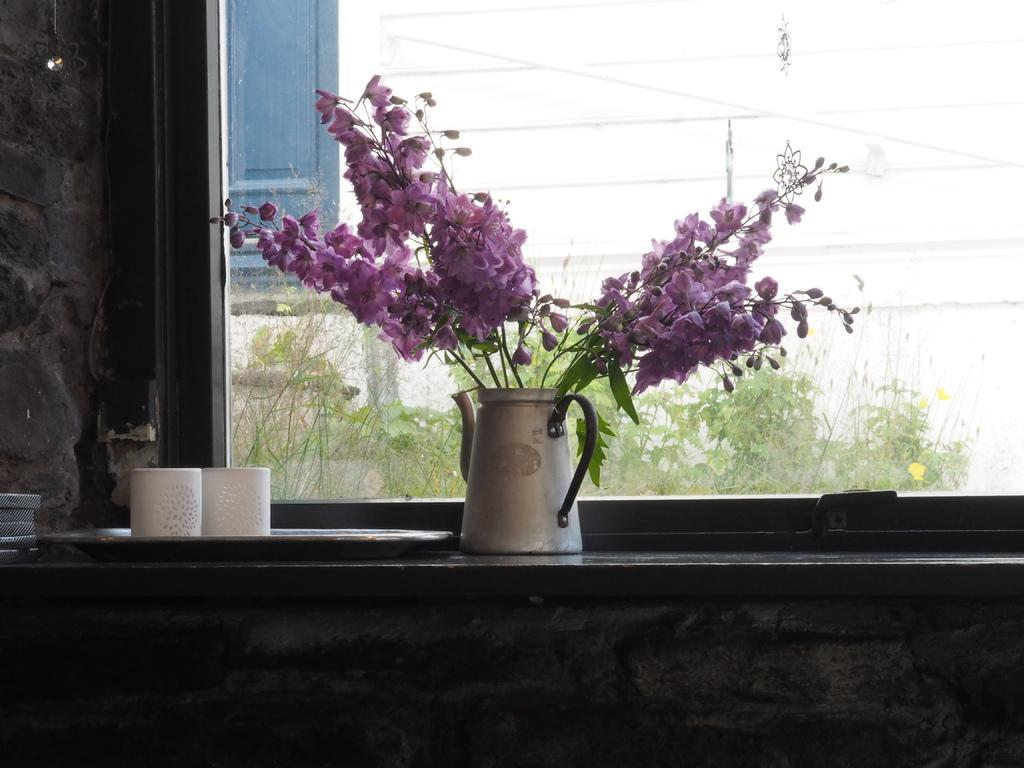What can be seen on the surface in the image? There are objects on the surface in the image. What type of natural elements are present in the image? There are trees in the image. What type of structure is visible in the image? There is a wall in the image. What allows light to enter the structure in the image? There are windows in the image. Can you see the flesh of the trees in the image? There is no mention of the trees' flesh in the image, and it is not visible in the provided facts. Is there a swing present in the image? There is no mention of a swing in the image, and it is not visible in the provided facts. 